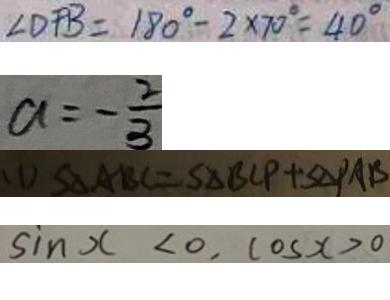Convert formula to latex. <formula><loc_0><loc_0><loc_500><loc_500>\angle D F B = 1 8 0 ^ { \circ } - 2 \times 7 0 ^ { \circ } = 4 0 ^ { \circ } 
 a = - \frac { 2 } { 3 } 
 ( 1 ) S _ { \Delta } A B C = S _ { \Delta } B C P + S _ { \Delta } P A B 
 \sin x < 0 , \cos x > 0</formula> 